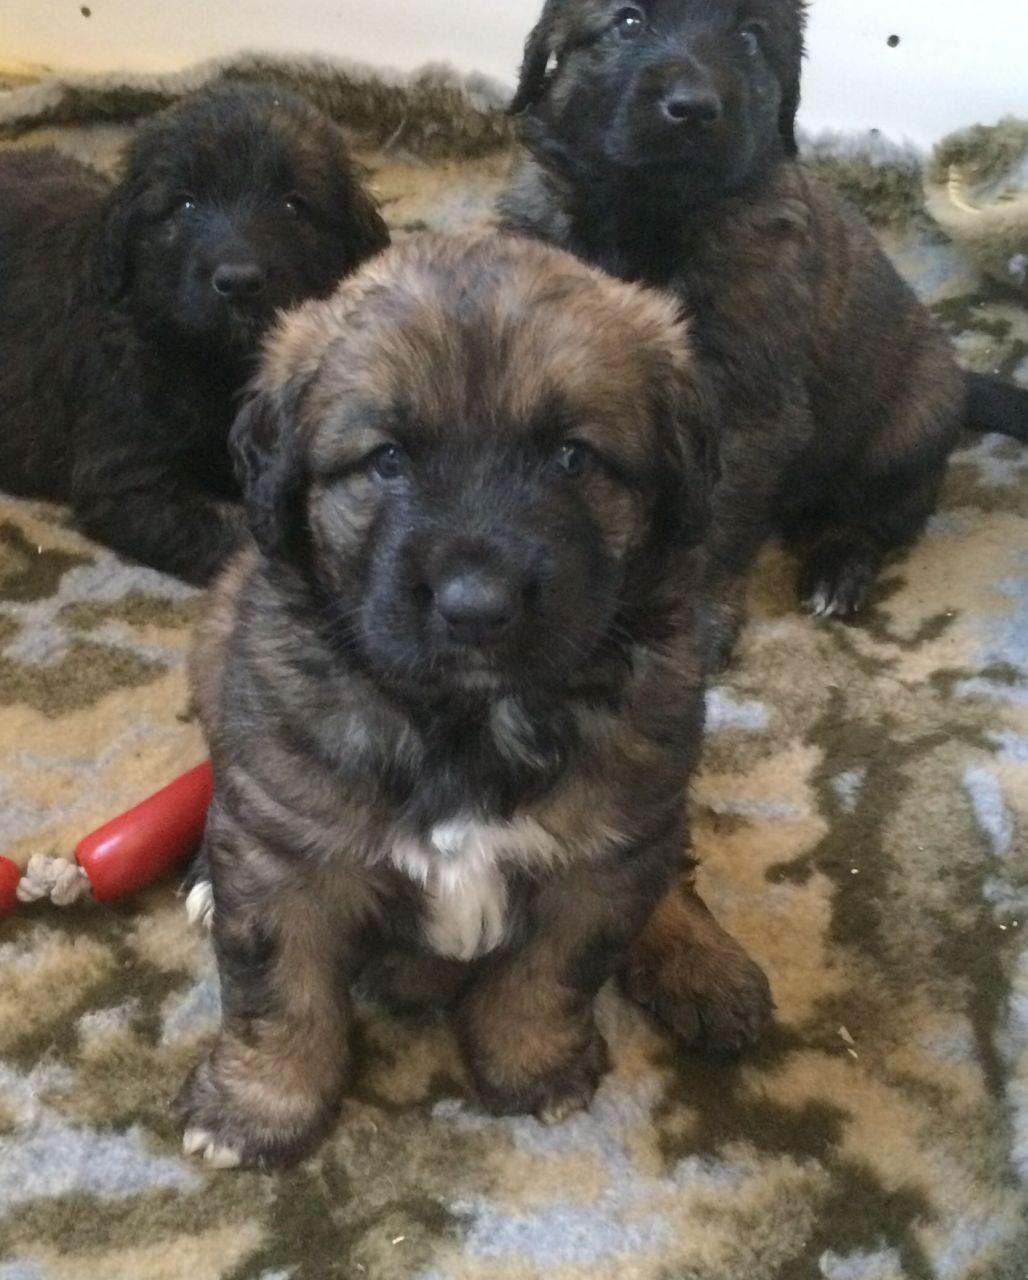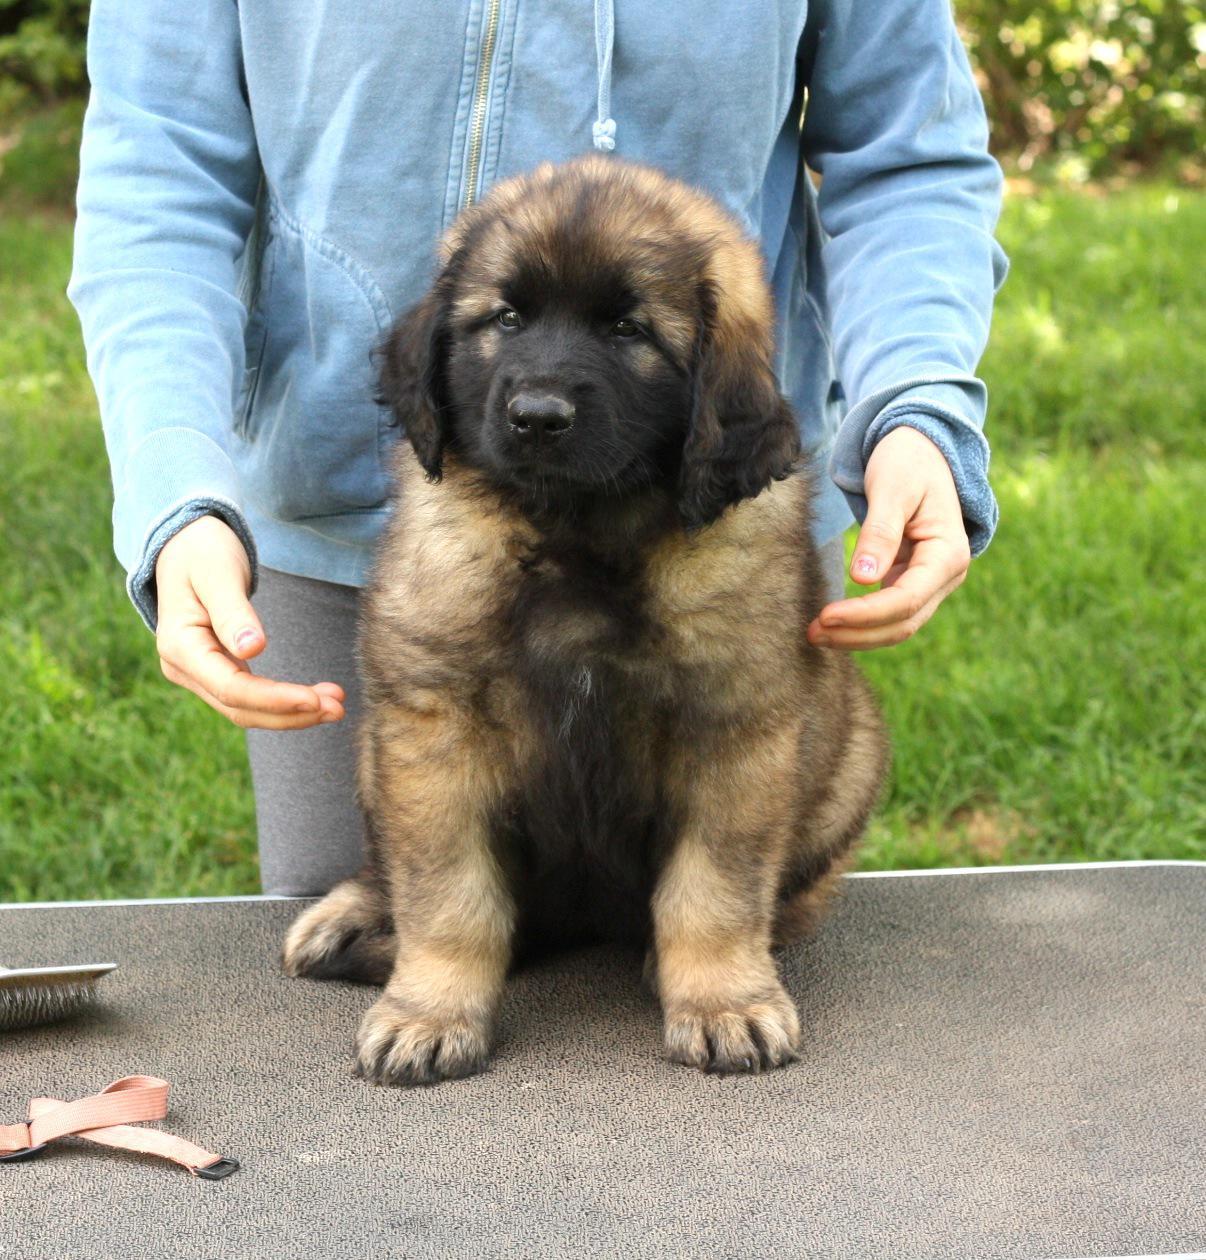The first image is the image on the left, the second image is the image on the right. Evaluate the accuracy of this statement regarding the images: "An image includes a person behind a dog's head, with a hand near the side of the dog's head.". Is it true? Answer yes or no. Yes. 